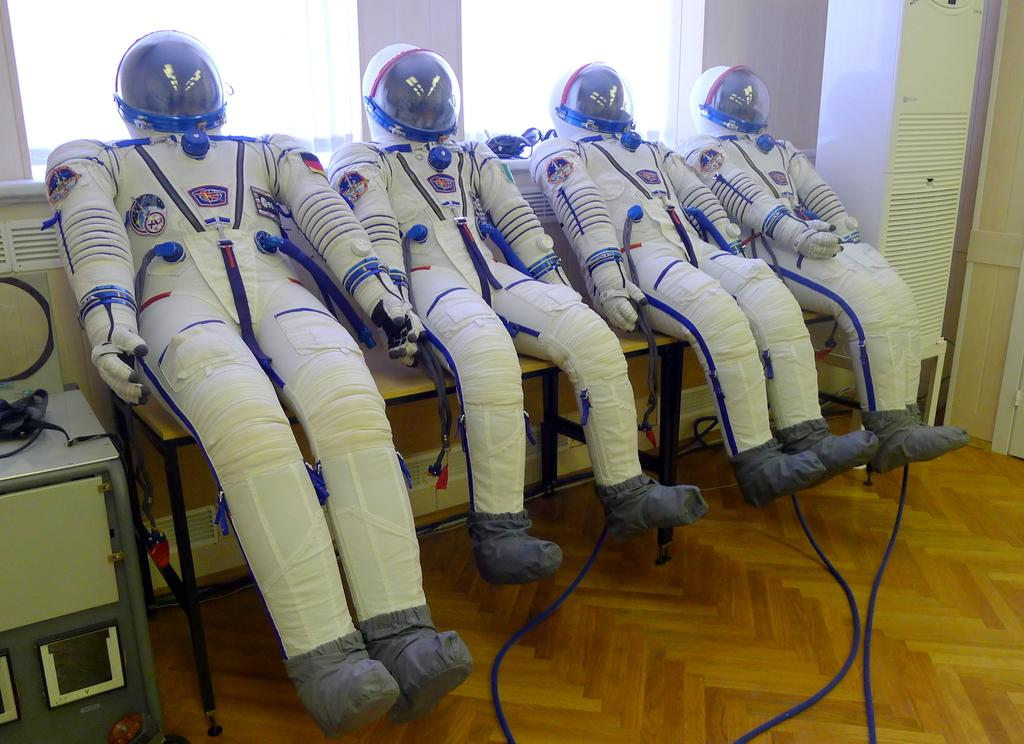What type of clothing is on the table in the image? There are space suits on a table in the image. What can be seen through the windows in the image? The details of what can be seen through the windows are not provided, but windows are visible in the image. What else is present on the floor in the image? There are other objects on the floor in the image, but their specific nature is not mentioned. What type of nut is being cracked by the bone in the image? There is no nut or bone present in the image; it features space suits on a table and other objects on the floor. What type of shade is covering the space suits in the image? There is no shade covering the space suits in the image; they are on a table with other objects visible in the room. 